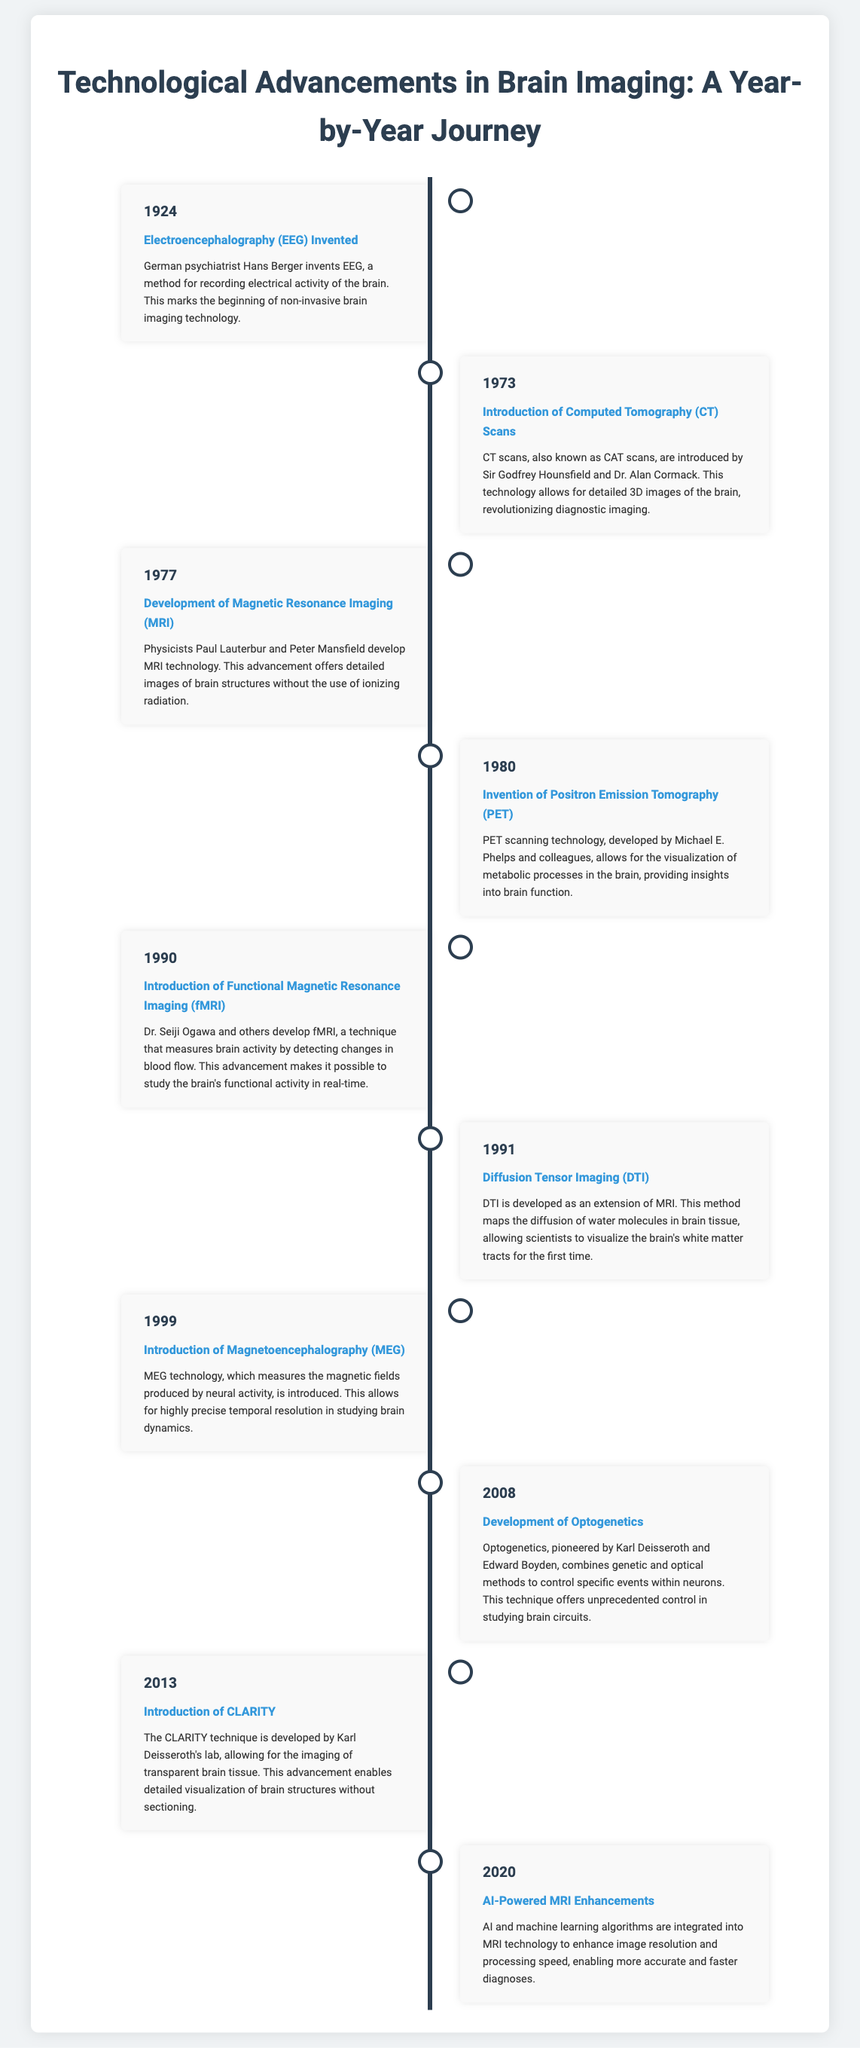What year was Electroencephalography (EEG) invented? The document states that EEG was invented in the year 1924.
Answer: 1924 Who developed Functional Magnetic Resonance Imaging (fMRI)? Dr. Seiji Ogawa and others are credited with the development of fMRI.
Answer: Dr. Seiji Ogawa What does PET stand for? The abbreviation PET in the document refers to Positron Emission Tomography.
Answer: Positron Emission Tomography What imaging technique was introduced in 1999? The document mentions that Magnetoencephalography (MEG) was introduced in 1999.
Answer: Magnetoencephalography (MEG) Which technology measures changes in blood flow in the brain? The timeline highlights that Functional Magnetic Resonance Imaging (fMRI) measures changes in blood flow.
Answer: Functional Magnetic Resonance Imaging (fMRI) What significant development occurred in 2008? The document notes the development of Optogenetics as a significant advancement in 2008.
Answer: Optogenetics Which technology was a precursor to non-invasive brain imaging? Electroencephalography (EEG) marks the beginning of non-invasive brain imaging technology.
Answer: Electroencephalography (EEG) What is a unique feature of Diffusion Tensor Imaging (DTI)? DTI maps the diffusion of water molecules in brain tissue, allowing visualization of white matter tracts.
Answer: Visualization of white matter tracts What year saw the integration of AI with MRI technology? The introduction of AI-powered enhancements to MRI technology occurred in the year 2020.
Answer: 2020 